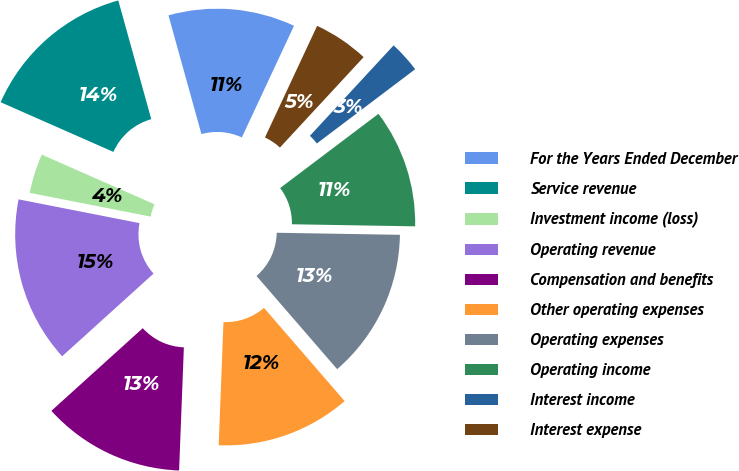Convert chart. <chart><loc_0><loc_0><loc_500><loc_500><pie_chart><fcel>For the Years Ended December<fcel>Service revenue<fcel>Investment income (loss)<fcel>Operating revenue<fcel>Compensation and benefits<fcel>Other operating expenses<fcel>Operating expenses<fcel>Operating income<fcel>Interest income<fcel>Interest expense<nl><fcel>11.27%<fcel>14.08%<fcel>3.52%<fcel>14.79%<fcel>12.68%<fcel>11.97%<fcel>13.38%<fcel>10.56%<fcel>2.82%<fcel>4.93%<nl></chart> 